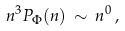<formula> <loc_0><loc_0><loc_500><loc_500>n ^ { 3 } P _ { \Phi } ( n ) \, \sim \, n ^ { 0 } \, ,</formula> 